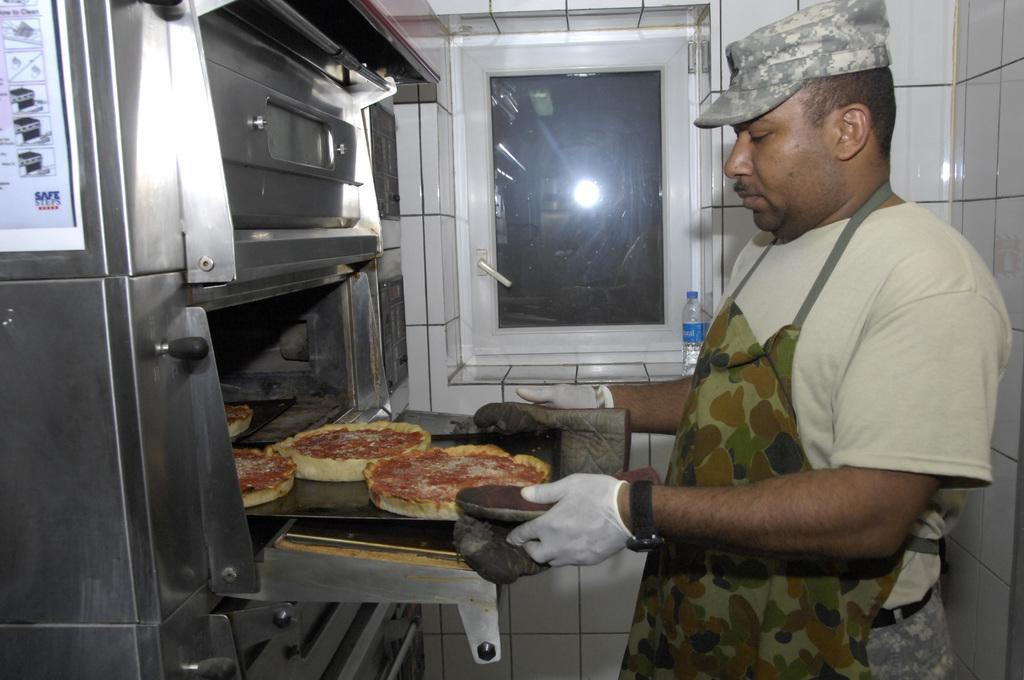<image>
Write a terse but informative summary of the picture. an oven with directions next to them that says safe 